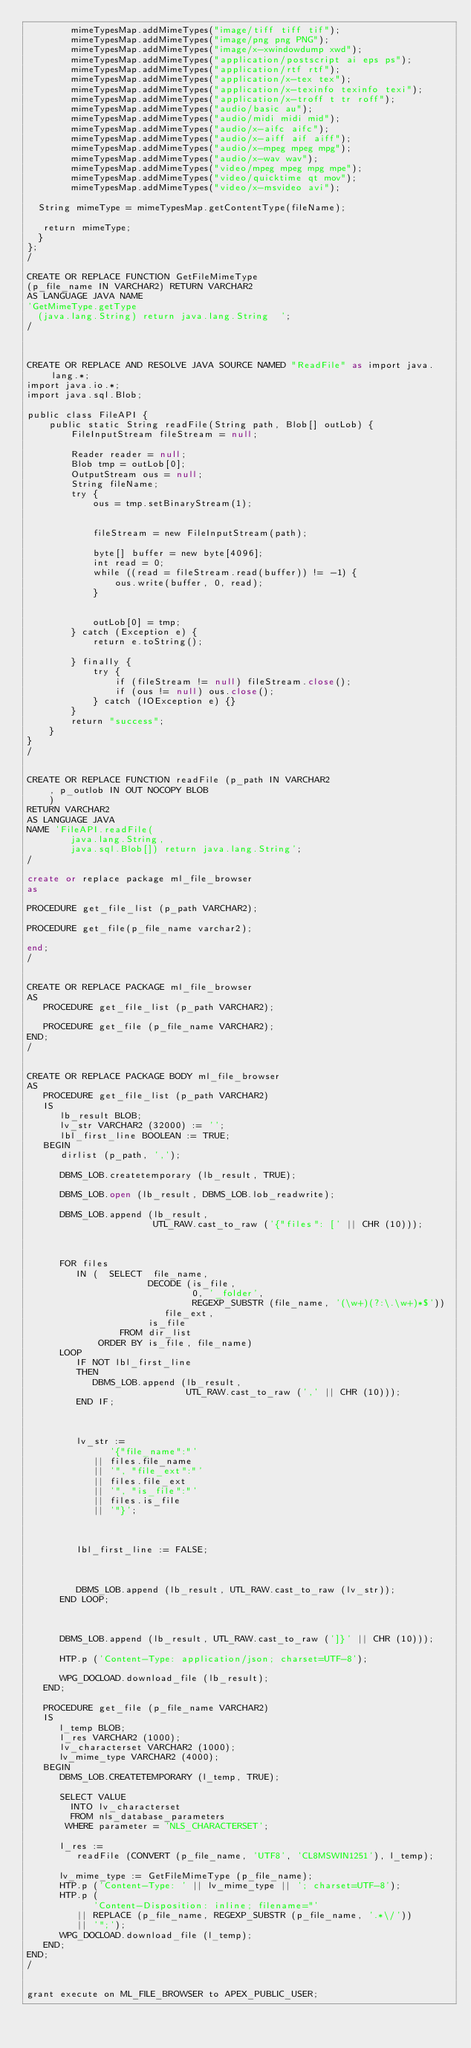Convert code to text. <code><loc_0><loc_0><loc_500><loc_500><_SQL_>        mimeTypesMap.addMimeTypes("image/tiff tiff tif");
        mimeTypesMap.addMimeTypes("image/png png PNG");
        mimeTypesMap.addMimeTypes("image/x-xwindowdump xwd");
        mimeTypesMap.addMimeTypes("application/postscript ai eps ps");
        mimeTypesMap.addMimeTypes("application/rtf rtf");
        mimeTypesMap.addMimeTypes("application/x-tex tex");
        mimeTypesMap.addMimeTypes("application/x-texinfo texinfo texi");
        mimeTypesMap.addMimeTypes("application/x-troff t tr roff");
        mimeTypesMap.addMimeTypes("audio/basic au");
        mimeTypesMap.addMimeTypes("audio/midi midi mid");
        mimeTypesMap.addMimeTypes("audio/x-aifc aifc");
        mimeTypesMap.addMimeTypes("audio/x-aiff aif aiff");
        mimeTypesMap.addMimeTypes("audio/x-mpeg mpeg mpg");
        mimeTypesMap.addMimeTypes("audio/x-wav wav");
        mimeTypesMap.addMimeTypes("video/mpeg mpeg mpg mpe");
        mimeTypesMap.addMimeTypes("video/quicktime qt mov");
        mimeTypesMap.addMimeTypes("video/x-msvideo avi");
  
  String mimeType = mimeTypesMap.getContentType(fileName);
  
   return mimeType;
  }
};
/

CREATE OR REPLACE FUNCTION GetFileMimeType
(p_file_name IN VARCHAR2) RETURN VARCHAR2
AS LANGUAGE JAVA NAME
'GetMimeType.getType
  (java.lang.String) return java.lang.String  ';
/



CREATE OR REPLACE AND RESOLVE JAVA SOURCE NAMED "ReadFile" as import java.lang.*;
import java.io.*;
import java.sql.Blob;

public class FileAPI {
    public static String readFile(String path, Blob[] outLob) {
        FileInputStream fileStream = null;

        Reader reader = null;
        Blob tmp = outLob[0];
        OutputStream ous = null;
        String fileName;
        try {
            ous = tmp.setBinaryStream(1);


            fileStream = new FileInputStream(path);
            
            byte[] buffer = new byte[4096];
            int read = 0;
            while ((read = fileStream.read(buffer)) != -1) {
                ous.write(buffer, 0, read);
            }


            outLob[0] = tmp;
        } catch (Exception e) {
            return e.toString();
           
        } finally {
            try {
                if (fileStream != null) fileStream.close();
                if (ous != null) ous.close();
            } catch (IOException e) {}
        }
        return "success";
    }
}
/


CREATE OR REPLACE FUNCTION readFile (p_path IN VARCHAR2
    , p_outlob IN OUT NOCOPY BLOB
    )
RETURN VARCHAR2
AS LANGUAGE JAVA
NAME 'FileAPI.readFile(
        java.lang.String,
        java.sql.Blob[]) return java.lang.String';
/

create or replace package ml_file_browser
as

PROCEDURE get_file_list (p_path VARCHAR2);

PROCEDURE get_file(p_file_name varchar2);

end;
/


CREATE OR REPLACE PACKAGE ml_file_browser
AS
   PROCEDURE get_file_list (p_path VARCHAR2);

   PROCEDURE get_file (p_file_name VARCHAR2);
END;
/


CREATE OR REPLACE PACKAGE BODY ml_file_browser
AS
   PROCEDURE get_file_list (p_path VARCHAR2)
   IS
      lb_result BLOB;
      lv_str VARCHAR2 (32000) := '';
      lbl_first_line BOOLEAN := TRUE;
   BEGIN
      dirlist (p_path, ',');

      DBMS_LOB.createtemporary (lb_result, TRUE);

      DBMS_LOB.open (lb_result, DBMS_LOB.lob_readwrite);

      DBMS_LOB.append (lb_result,
                       UTL_RAW.cast_to_raw ('{"files": [' || CHR (10)));



      FOR files
         IN (  SELECT  file_name,
                      DECODE (is_file,
                              0, '_folder',
                              REGEXP_SUBSTR (file_name, '(\w+)(?:\.\w+)*$'))
                         file_ext,
                      is_file
                 FROM dir_list
             ORDER BY is_file, file_name)
      LOOP
         IF NOT lbl_first_line
         THEN
            DBMS_LOB.append (lb_result,
                             UTL_RAW.cast_to_raw (',' || CHR (10)));
         END IF;



         lv_str :=
               '{"file_name":"'
            || files.file_name
            || '", "file_ext":"'
            || files.file_ext
            || '", "is_file":"'
            || files.is_file
            || '"}';



         lbl_first_line := FALSE;



         DBMS_LOB.append (lb_result, UTL_RAW.cast_to_raw (lv_str));
      END LOOP;



      DBMS_LOB.append (lb_result, UTL_RAW.cast_to_raw (']}' || CHR (10)));

      HTP.p ('Content-Type: application/json; charset=UTF-8');

      WPG_DOCLOAD.download_file (lb_result);
   END;

   PROCEDURE get_file (p_file_name VARCHAR2)
   IS
      l_temp BLOB;
      l_res VARCHAR2 (1000);
      lv_characterset VARCHAR2 (1000);
      lv_mime_type VARCHAR2 (4000);
   BEGIN
      DBMS_LOB.CREATETEMPORARY (l_temp, TRUE);

      SELECT VALUE
        INTO lv_characterset
        FROM nls_database_parameters
       WHERE parameter = 'NLS_CHARACTERSET';

      l_res :=
         readFile (CONVERT (p_file_name, 'UTF8', 'CL8MSWIN1251'), l_temp);

      lv_mime_type := GetFileMimeType (p_file_name);
      HTP.p ('Content-Type: ' || lv_mime_type || '; charset=UTF-8');
      HTP.p (
            'Content-Disposition: inline; filename="'
         || REPLACE (p_file_name, REGEXP_SUBSTR (p_file_name, '.*\/'))
         || '";');
      WPG_DOCLOAD.download_file (l_temp);
   END;
END;
/


grant execute on ML_FILE_BROWSER to APEX_PUBLIC_USER;</code> 